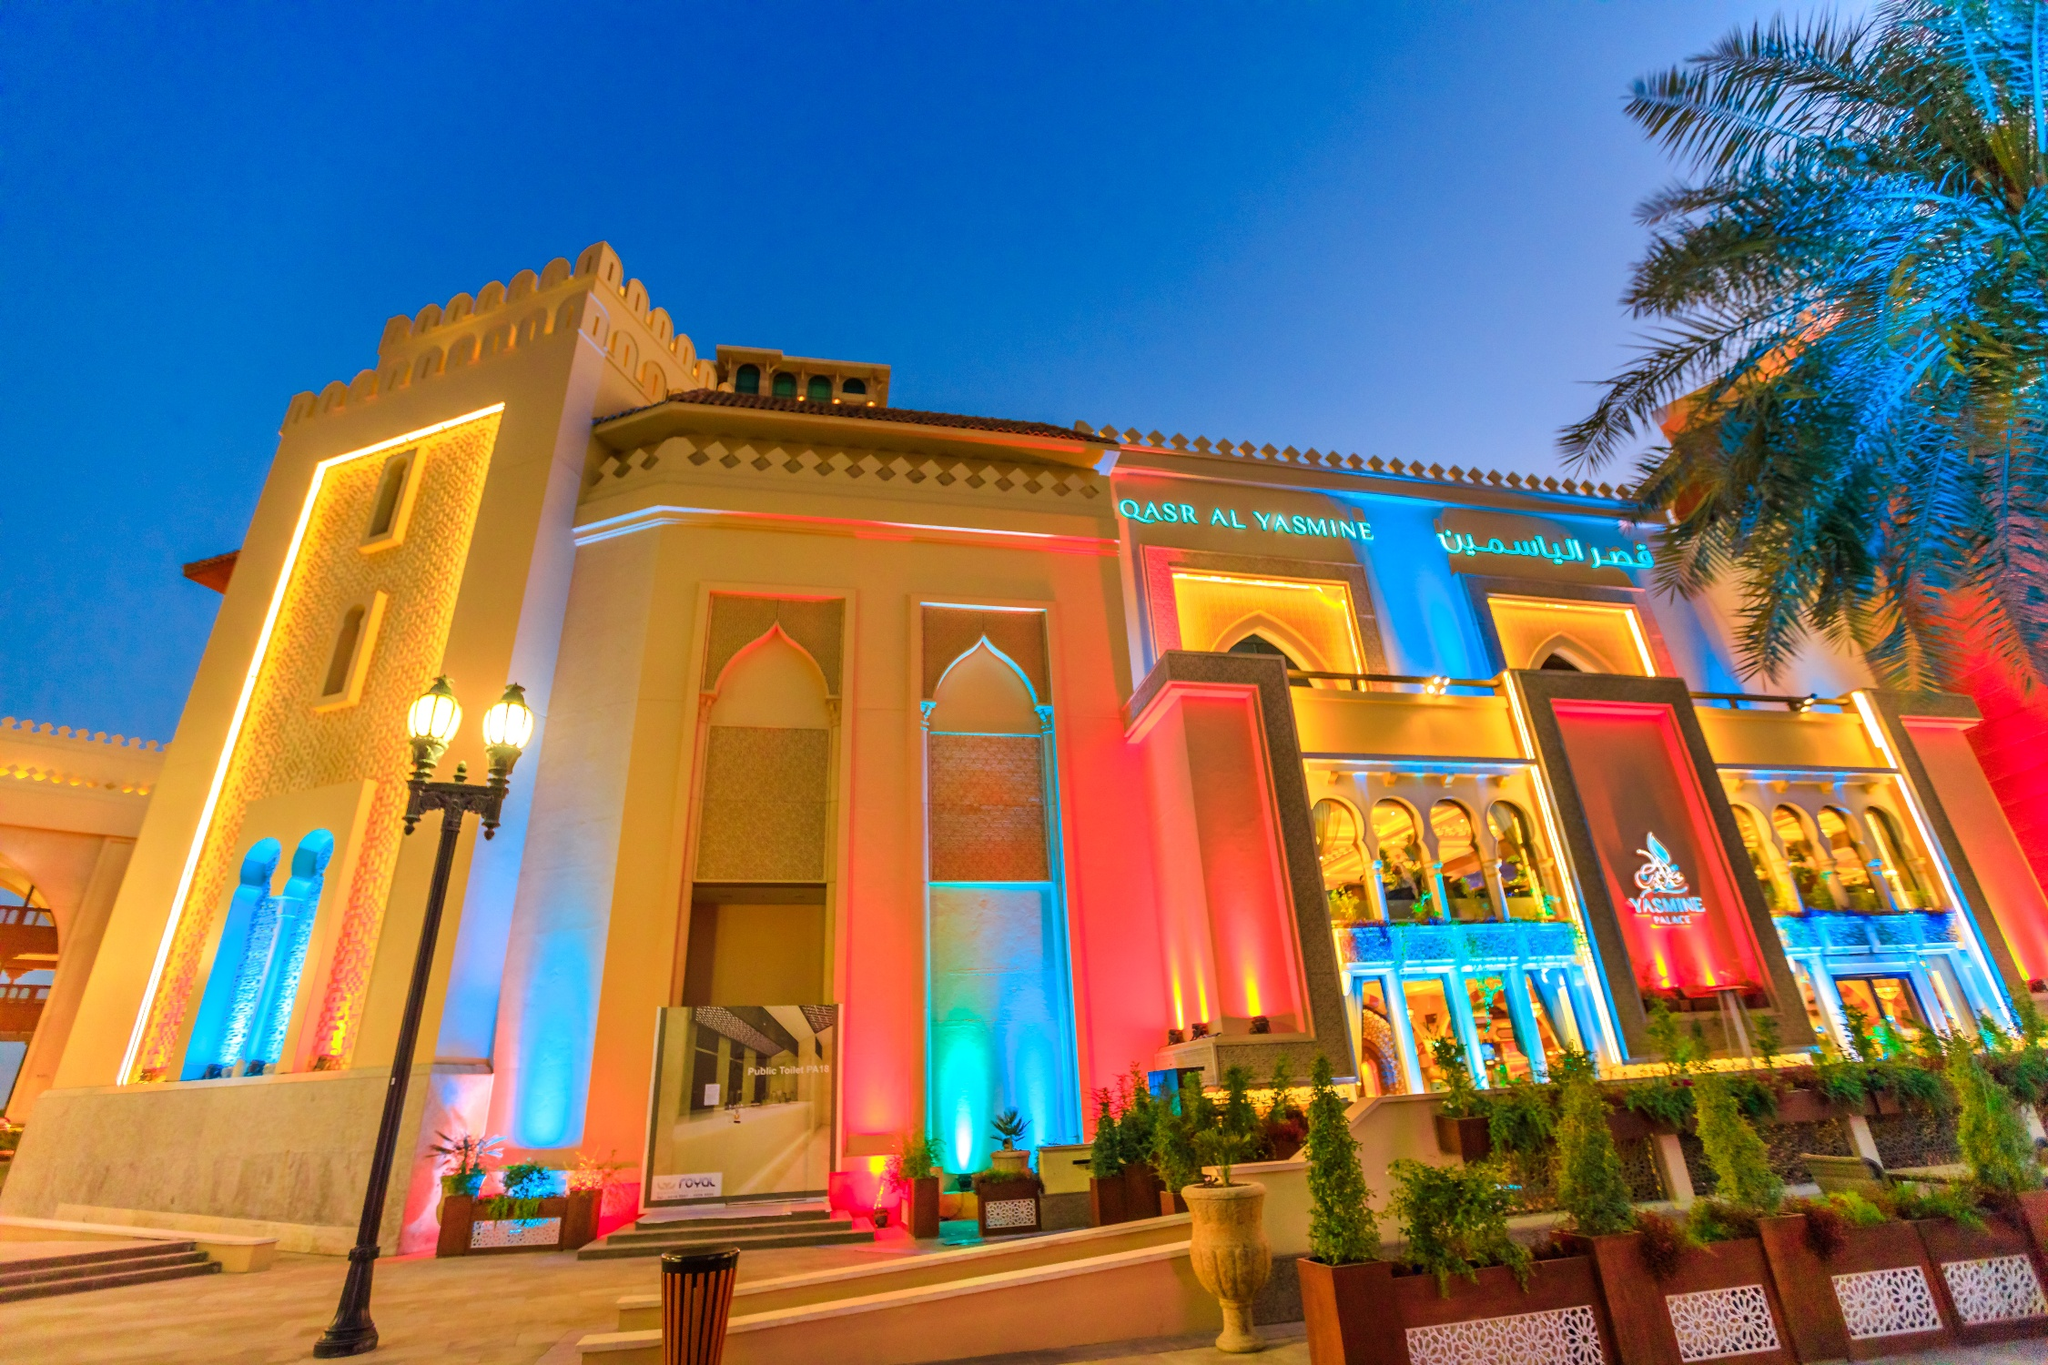What role does Qasr Al Watan play in the cultural or political landscape of the UAE? Qasr Al Watan is more than just a presidential palace; it's a beacon of cultural pride and political significance in the UAE. Open to the public, it serves as a cultural hub that educates visitors about the governance, heritage, and arts of the UAE. Politically, it hosts state visits and official summits, representing a platform where governance meets culture. 